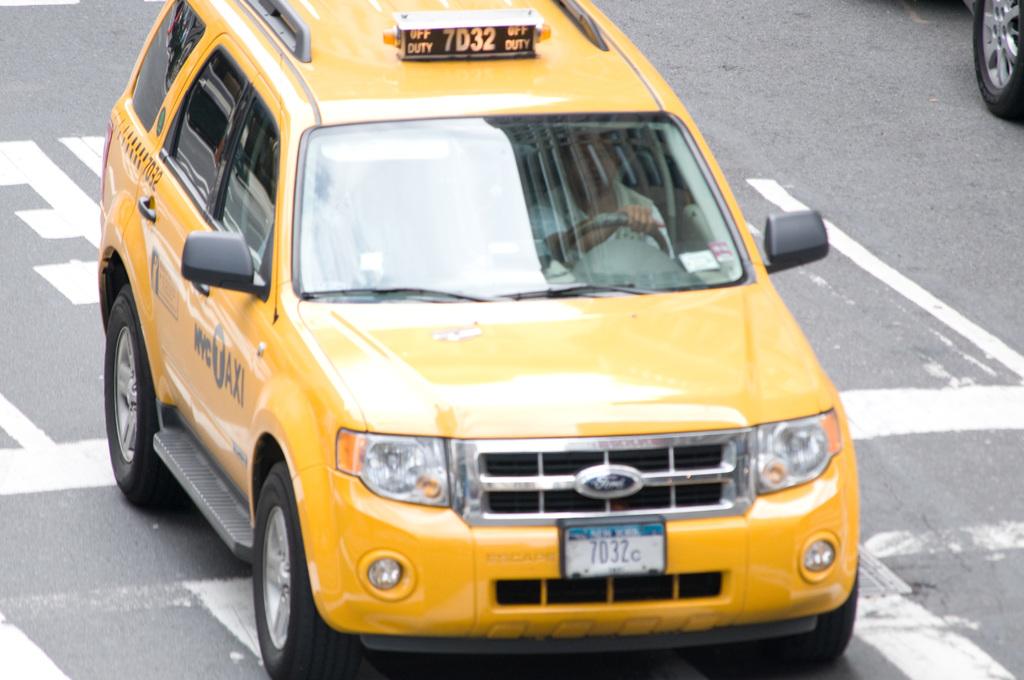What number is the license plate?
Your response must be concise. 7032. Collection adult books?
Make the answer very short. Unanswerable. 